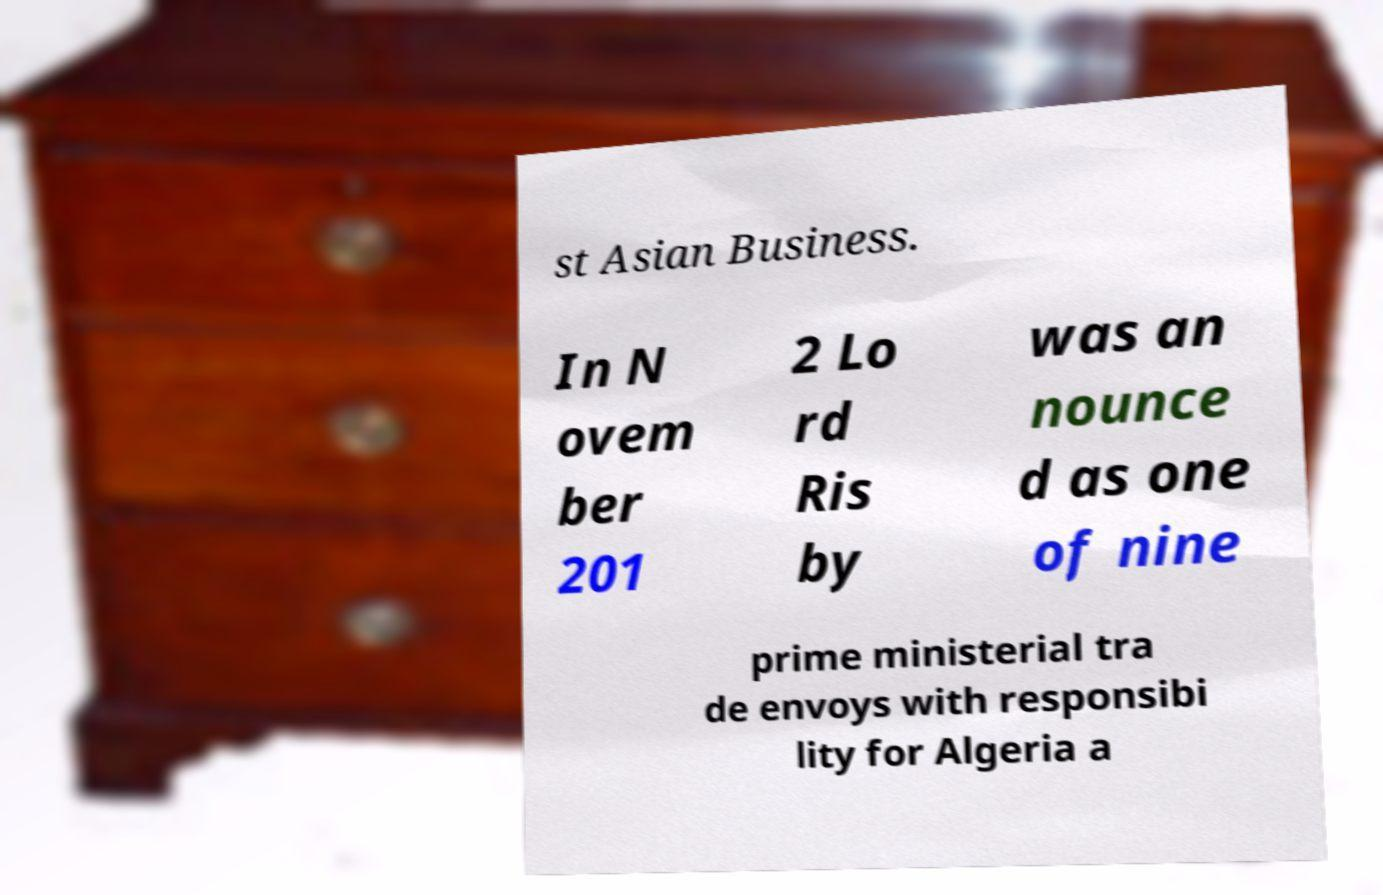Could you assist in decoding the text presented in this image and type it out clearly? st Asian Business. In N ovem ber 201 2 Lo rd Ris by was an nounce d as one of nine prime ministerial tra de envoys with responsibi lity for Algeria a 